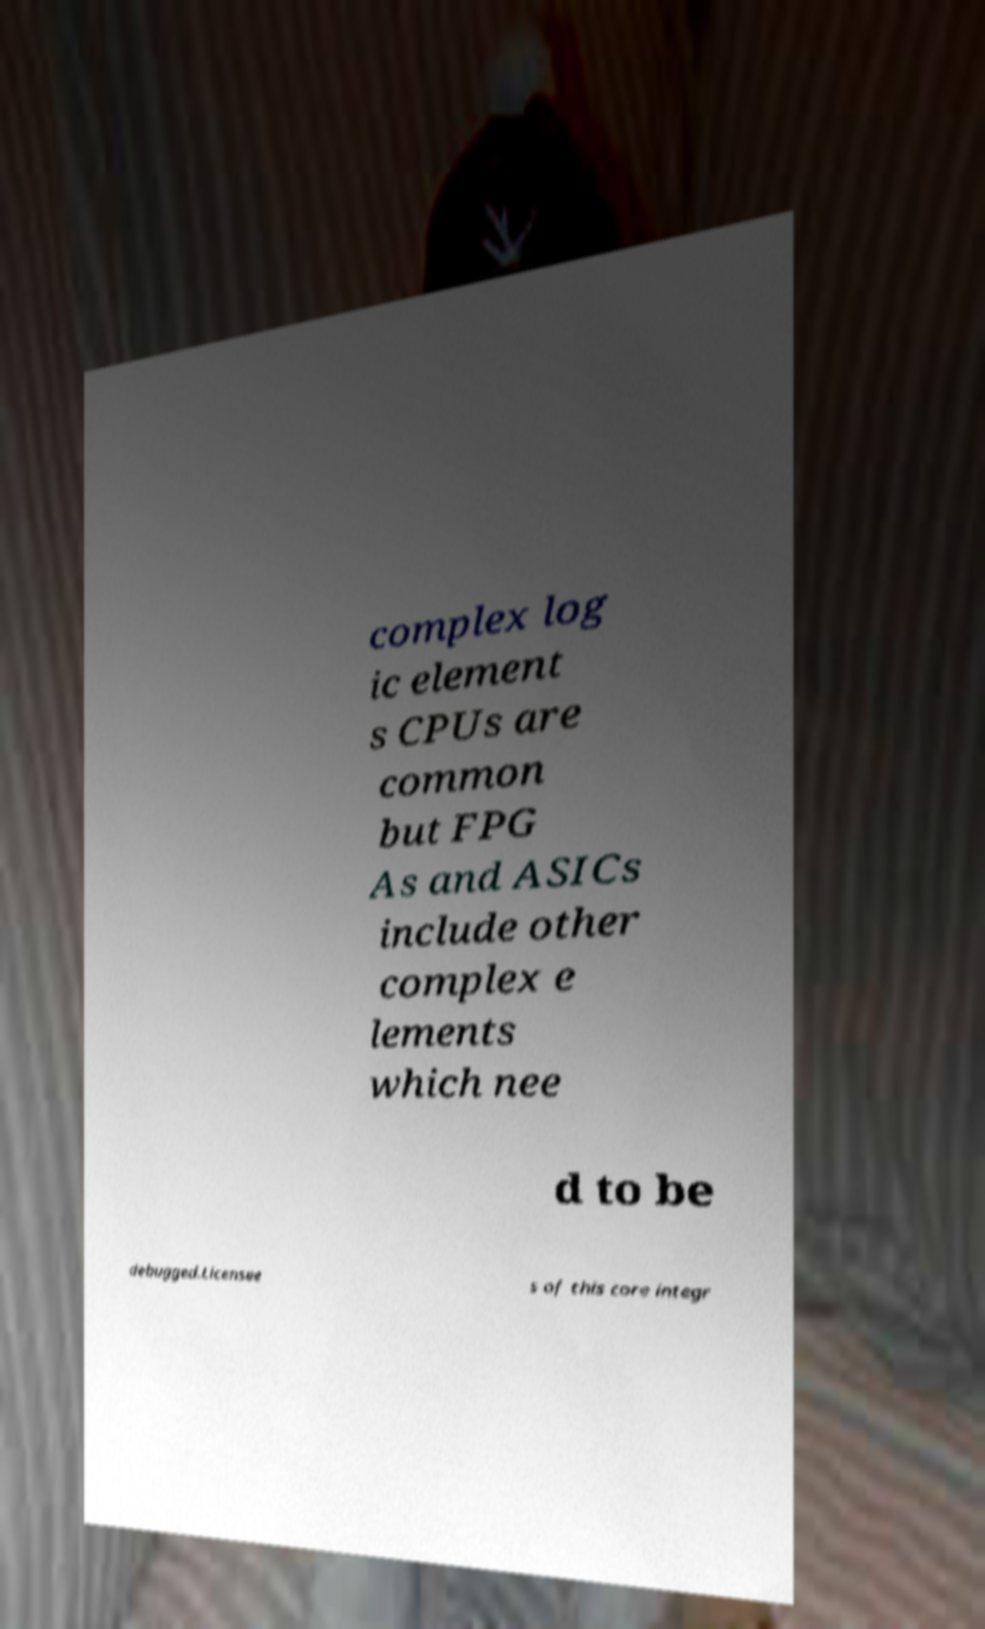Could you extract and type out the text from this image? complex log ic element s CPUs are common but FPG As and ASICs include other complex e lements which nee d to be debugged.Licensee s of this core integr 